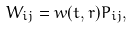Convert formula to latex. <formula><loc_0><loc_0><loc_500><loc_500>W _ { i j } = w ( t , r ) P _ { i j } ,</formula> 